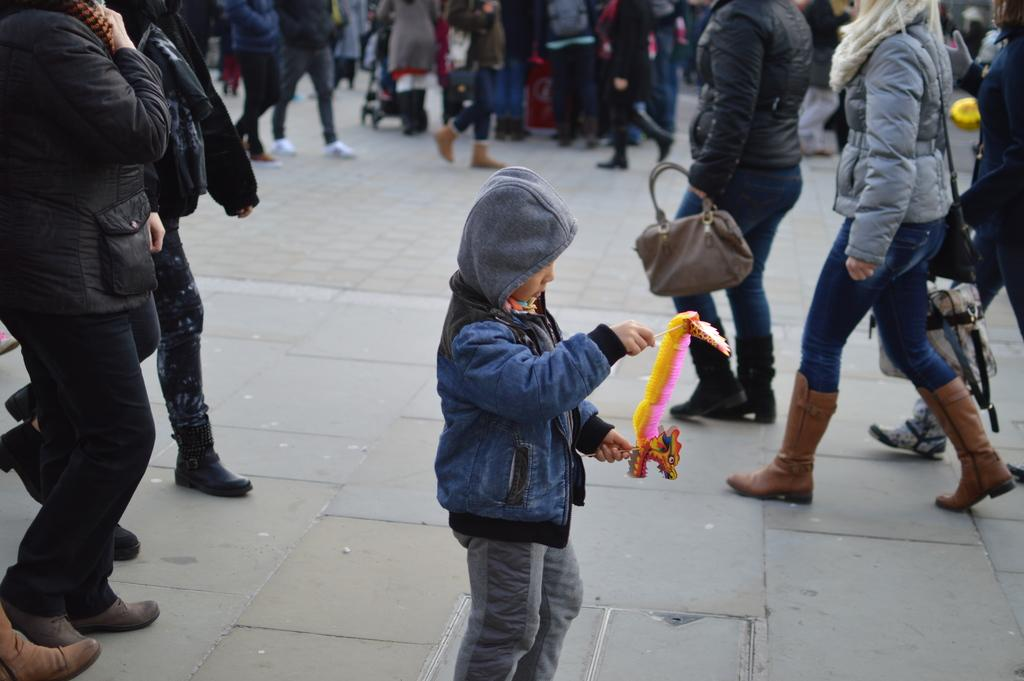What is happening in the image? There is a crowd in the image, and people are walking on the road. What are some people doing while walking on the road? Some people are carrying bags. Can you describe the boy in the foreground? In the foreground, there is a boy holding an object. What type of wool is the boy spinning in the image? There is no wool or spinning activity present in the image. Can you recite the verse that the people in the crowd are chanting? There is no chanting or verse present in the image. 